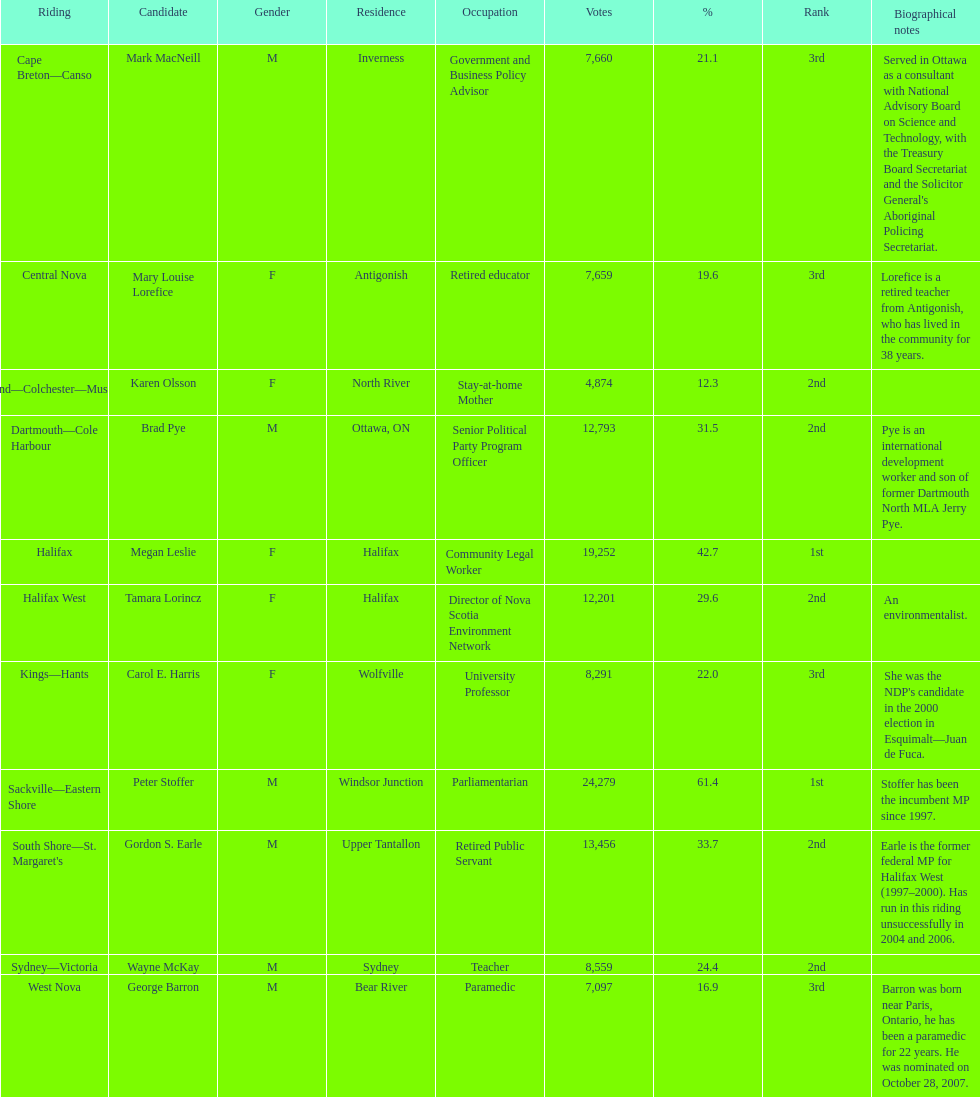Inform me of the overall amount of votes the female candidates received. 52,277. 